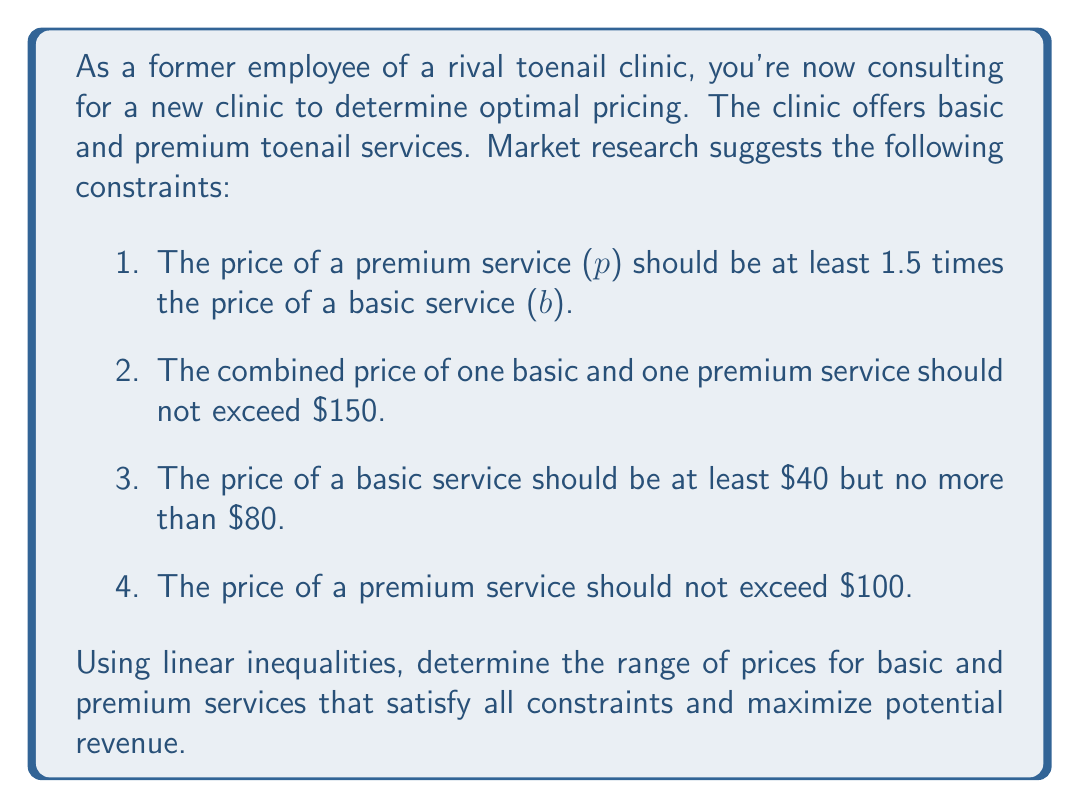Can you answer this question? Let's approach this step-by-step using linear inequalities:

1. $p \geq 1.5b$ (premium price at least 1.5 times basic price)
2. $b + p \leq 150$ (combined price not exceeding $150)
3. $40 \leq b \leq 80$ (basic price between $40 and $80)
4. $p \leq 100$ (premium price not exceeding $100)

To solve this system of inequalities:

a) From constraint 3, we know the bounds for $b$: $40 \leq b \leq 80$

b) From constraint 1 and the upper bound of $b$:
   $p \geq 1.5b$
   $p \geq 1.5(80) = 120$ (maximum possible lower bound for $p$)

c) However, this contradicts constraint 4 ($p \leq 100$). So, we need to find the maximum $b$ that allows $p \leq 100$:
   $1.5b \leq 100$
   $b \leq 66.67$

d) Therefore, the actual range for $b$ is: $40 \leq b \leq 66.67$

e) For $p$, we have:
   Lower bound: $p \geq 1.5b \geq 1.5(40) = 60$
   Upper bound: $p \leq 100$

f) We also need to check constraint 2:
   $b + p \leq 150$
   At maximum values: $66.67 + 100 = 166.67 > 150$
   So this constraint further restricts our upper bounds.

g) To maximize revenue, we want to set prices as high as possible within constraints. The optimal point will be where constraints 1 and 2 intersect:
   $p = 1.5b$ and $b + p = 150$
   Substituting: $b + 1.5b = 150$
   $2.5b = 150$
   $b = 60$
   $p = 1.5(60) = 90$

Therefore, the optimal pricing range is:
For basic service ($b$): $40 \leq b \leq 60$
For premium service ($p$): $60 \leq p \leq 90$
Answer: The optimal pricing range that satisfies all constraints and maximizes potential revenue is:
Basic service: $40 \leq b \leq 60$
Premium service: $60 \leq p \leq 90$ 